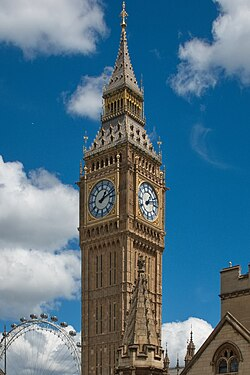What is this photo about? The photo prominently features the esteemed Big Ben, an iconic clock tower in London, England. The architectural marvel is presented against a picturesque backdrop of a clear blue sky adorned with a scattering of white clouds. The tower is built with intricate brick detailing and culminates in a sharp spire. Each facet of the tower boasts a striking clock face with white dials and black markings, visible from any direction. Visible in the distance is the London Eye, further enriching the quintessential London scenery. The towering structure stands out majestically, its grandeur highlighted by the contrast between the brick tones and the vivid blue sky. 